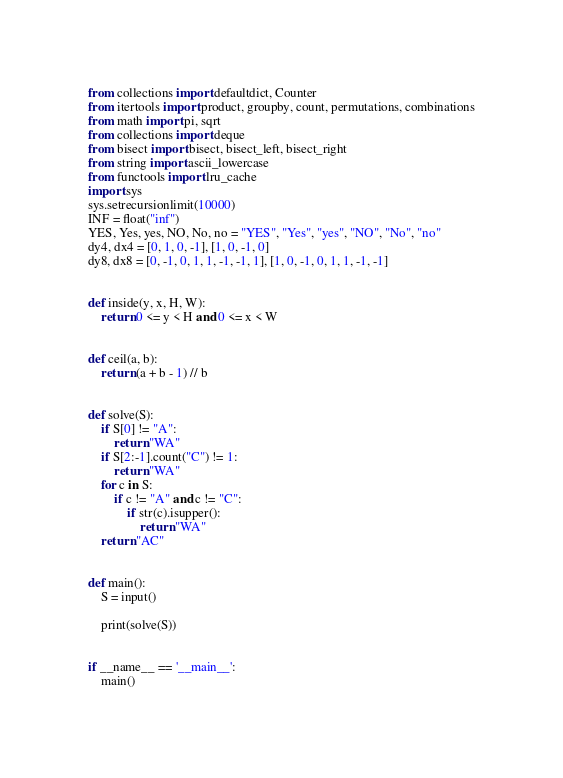Convert code to text. <code><loc_0><loc_0><loc_500><loc_500><_Python_>from collections import defaultdict, Counter
from itertools import product, groupby, count, permutations, combinations
from math import pi, sqrt
from collections import deque
from bisect import bisect, bisect_left, bisect_right
from string import ascii_lowercase
from functools import lru_cache
import sys
sys.setrecursionlimit(10000)
INF = float("inf")
YES, Yes, yes, NO, No, no = "YES", "Yes", "yes", "NO", "No", "no"
dy4, dx4 = [0, 1, 0, -1], [1, 0, -1, 0]
dy8, dx8 = [0, -1, 0, 1, 1, -1, -1, 1], [1, 0, -1, 0, 1, 1, -1, -1]


def inside(y, x, H, W):
    return 0 <= y < H and 0 <= x < W


def ceil(a, b):
    return (a + b - 1) // b


def solve(S):
    if S[0] != "A":
        return "WA"
    if S[2:-1].count("C") != 1:
        return "WA"
    for c in S:
        if c != "A" and c != "C":
            if str(c).isupper():
                return "WA"
    return "AC"


def main():
    S = input()

    print(solve(S))


if __name__ == '__main__':
    main()
</code> 